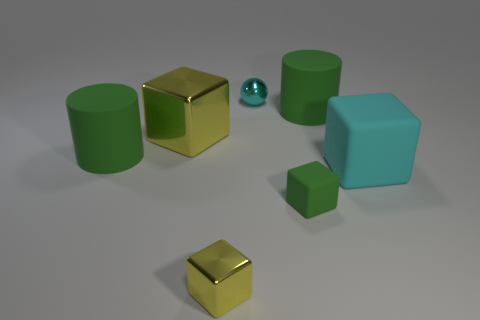Is the number of tiny objects that are on the right side of the green cube greater than the number of big green things in front of the large shiny block?
Provide a short and direct response. No. There is another metallic block that is the same color as the big shiny cube; what size is it?
Provide a short and direct response. Small. What color is the ball?
Your answer should be very brief. Cyan. There is a tiny thing that is behind the small yellow shiny cube and left of the tiny green rubber cube; what color is it?
Offer a terse response. Cyan. What color is the metallic thing that is in front of the large matte block right of the green cylinder that is on the left side of the cyan sphere?
Provide a short and direct response. Yellow. There is a shiny ball that is the same size as the green cube; what is its color?
Make the answer very short. Cyan. What shape is the large green thing that is behind the big green cylinder on the left side of the small shiny object in front of the cyan metal thing?
Your answer should be compact. Cylinder. What is the shape of the large thing that is the same color as the tiny sphere?
Your answer should be very brief. Cube. How many things are either red matte things or rubber blocks behind the green rubber cube?
Ensure brevity in your answer.  1. Does the matte cube in front of the cyan matte thing have the same size as the cyan block?
Your answer should be compact. No. 